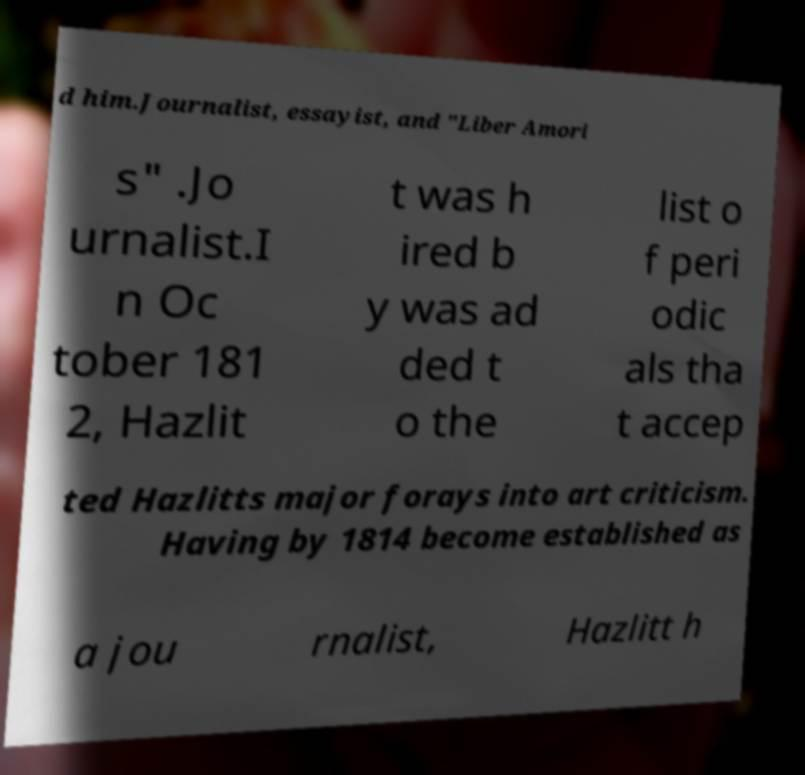Could you assist in decoding the text presented in this image and type it out clearly? d him.Journalist, essayist, and "Liber Amori s" .Jo urnalist.I n Oc tober 181 2, Hazlit t was h ired b y was ad ded t o the list o f peri odic als tha t accep ted Hazlitts major forays into art criticism. Having by 1814 become established as a jou rnalist, Hazlitt h 